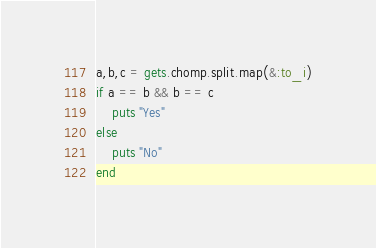<code> <loc_0><loc_0><loc_500><loc_500><_Ruby_>a,b,c = gets.chomp.split.map(&:to_i)
if a == b && b == c 
    puts "Yes"
else
    puts "No"
end</code> 